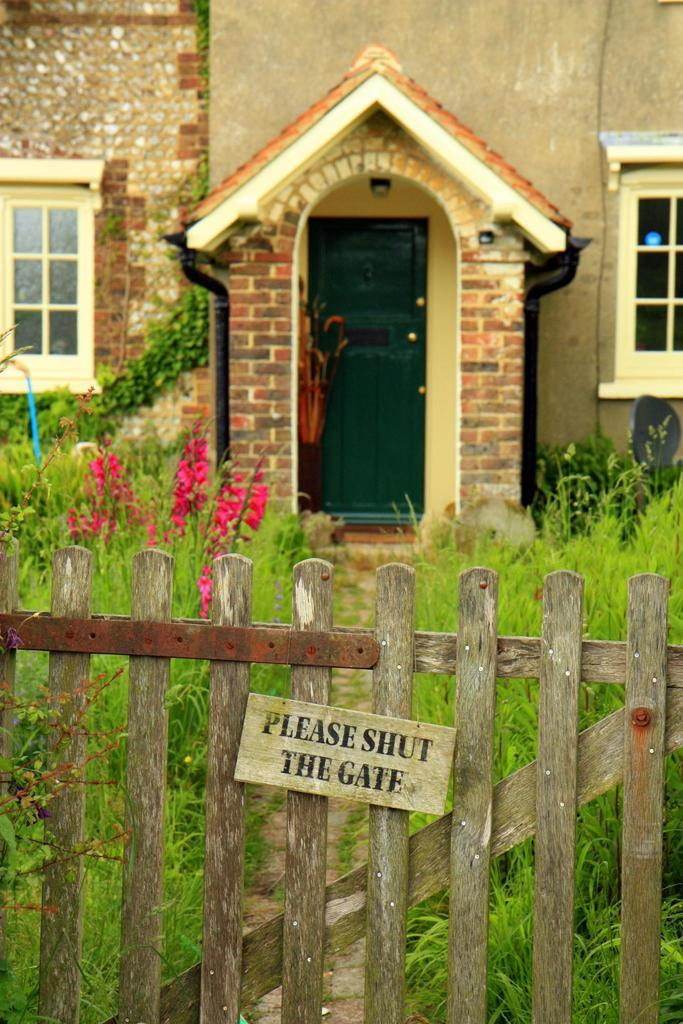What is located in the foreground of the image? There is a fence, grass, flowering plants, and creepers in the foreground of the image. What type of vegetation can be seen in the foreground? Flowering plants and creepers are visible in the foreground of the image. What is visible in the background of the image? There is a building and windows in the background of the image. Can you describe the time of day when the image was taken? The image was taken during the day. What type of paste is being used to stick the letters on the fence in the image? There are no letters or paste present in the image; it features a fence, grass, flowering plants, creepers, a building, and windows. How many bananas can be seen hanging from the creepers in the image? There are no bananas present in the image; it features a fence, grass, flowering plants, creepers, a building, and windows. 